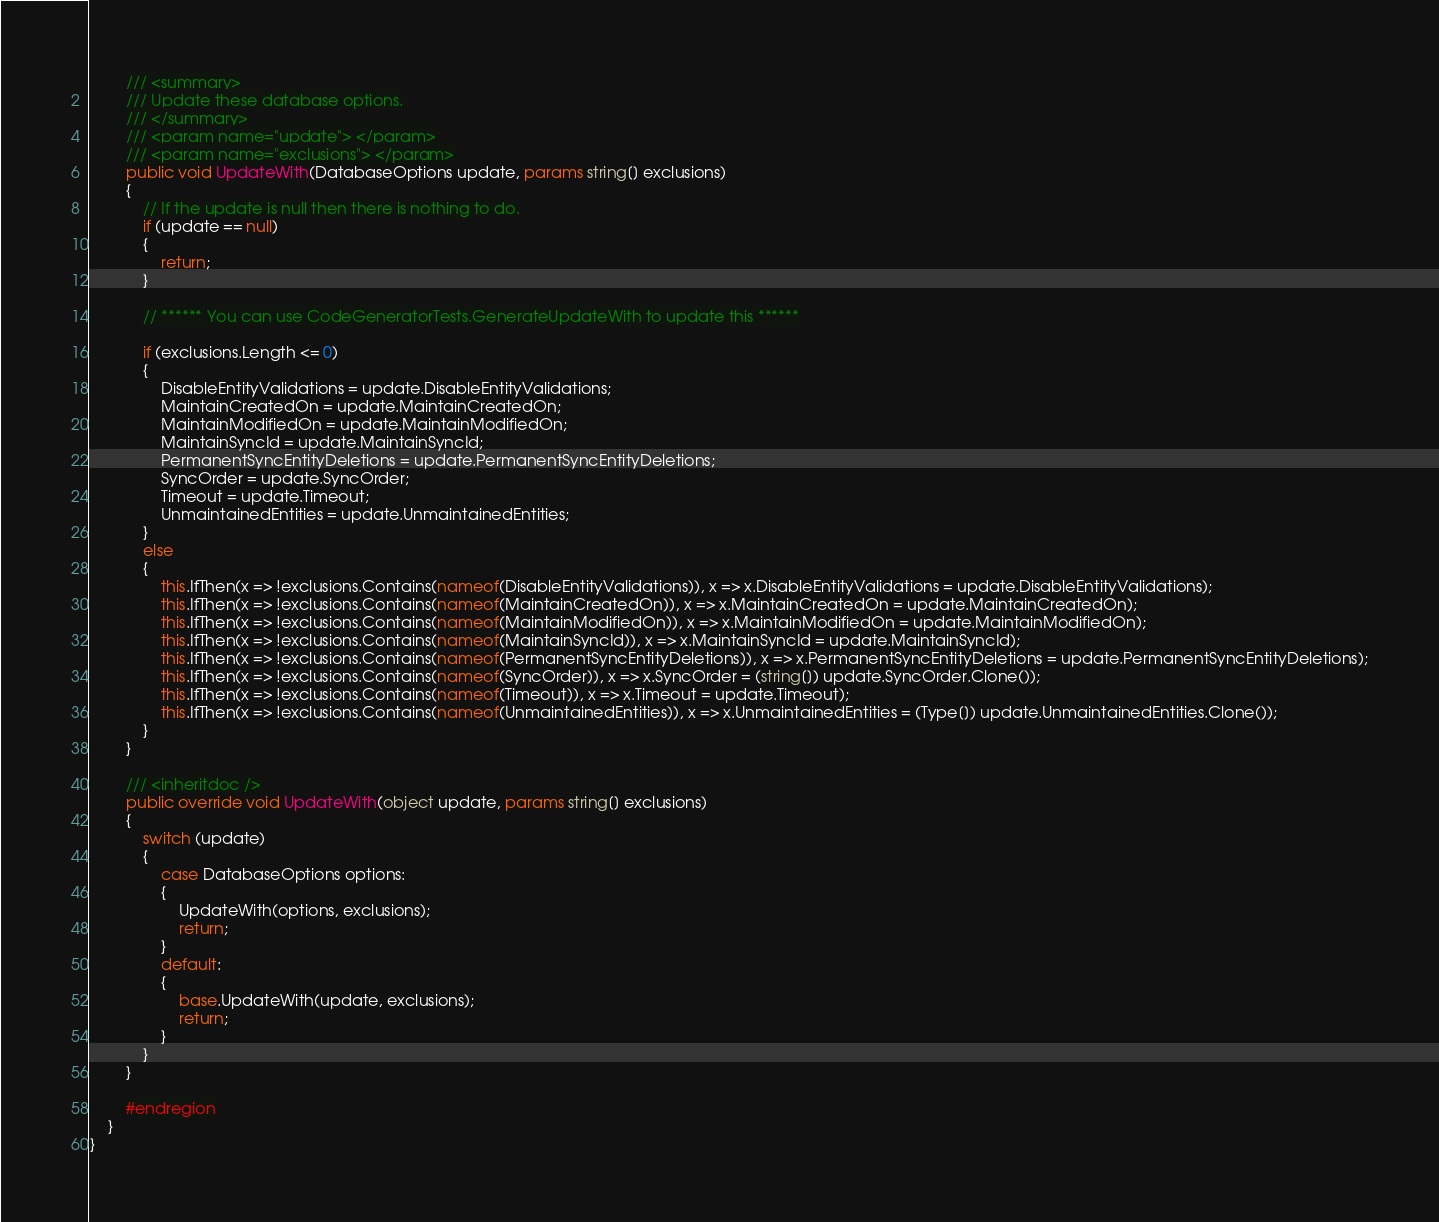Convert code to text. <code><loc_0><loc_0><loc_500><loc_500><_C#_>		/// <summary>
		/// Update these database options.
		/// </summary>
		/// <param name="update"> </param>
		/// <param name="exclusions"> </param>
		public void UpdateWith(DatabaseOptions update, params string[] exclusions)
		{
			// If the update is null then there is nothing to do.
			if (update == null)
			{
				return;
			}

			// ****** You can use CodeGeneratorTests.GenerateUpdateWith to update this ******

			if (exclusions.Length <= 0)
			{
				DisableEntityValidations = update.DisableEntityValidations;
				MaintainCreatedOn = update.MaintainCreatedOn;
				MaintainModifiedOn = update.MaintainModifiedOn;
				MaintainSyncId = update.MaintainSyncId;
				PermanentSyncEntityDeletions = update.PermanentSyncEntityDeletions;
				SyncOrder = update.SyncOrder;
				Timeout = update.Timeout;
				UnmaintainedEntities = update.UnmaintainedEntities;
			}
			else
			{
				this.IfThen(x => !exclusions.Contains(nameof(DisableEntityValidations)), x => x.DisableEntityValidations = update.DisableEntityValidations);
				this.IfThen(x => !exclusions.Contains(nameof(MaintainCreatedOn)), x => x.MaintainCreatedOn = update.MaintainCreatedOn);
				this.IfThen(x => !exclusions.Contains(nameof(MaintainModifiedOn)), x => x.MaintainModifiedOn = update.MaintainModifiedOn);
				this.IfThen(x => !exclusions.Contains(nameof(MaintainSyncId)), x => x.MaintainSyncId = update.MaintainSyncId);
				this.IfThen(x => !exclusions.Contains(nameof(PermanentSyncEntityDeletions)), x => x.PermanentSyncEntityDeletions = update.PermanentSyncEntityDeletions);
				this.IfThen(x => !exclusions.Contains(nameof(SyncOrder)), x => x.SyncOrder = (string[]) update.SyncOrder.Clone());
				this.IfThen(x => !exclusions.Contains(nameof(Timeout)), x => x.Timeout = update.Timeout);
				this.IfThen(x => !exclusions.Contains(nameof(UnmaintainedEntities)), x => x.UnmaintainedEntities = (Type[]) update.UnmaintainedEntities.Clone());
			}
		}

		/// <inheritdoc />
		public override void UpdateWith(object update, params string[] exclusions)
		{
			switch (update)
			{
				case DatabaseOptions options:
				{
					UpdateWith(options, exclusions);
					return;
				}
				default:
				{
					base.UpdateWith(update, exclusions);
					return;
				}
			}
		}

		#endregion
	}
}</code> 